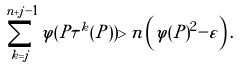<formula> <loc_0><loc_0><loc_500><loc_500>\sum _ { k = j } ^ { n + j - 1 } \varphi ( P \tau ^ { k } ( P ) ) > n \left ( \varphi ( P ) ^ { 2 } - \varepsilon \right ) .</formula> 